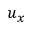<formula> <loc_0><loc_0><loc_500><loc_500>u _ { x }</formula> 